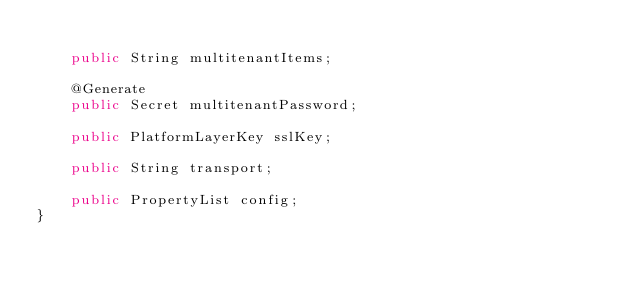Convert code to text. <code><loc_0><loc_0><loc_500><loc_500><_Java_>
	public String multitenantItems;

	@Generate
	public Secret multitenantPassword;

	public PlatformLayerKey sslKey;

	public String transport;

	public PropertyList config;
}
</code> 